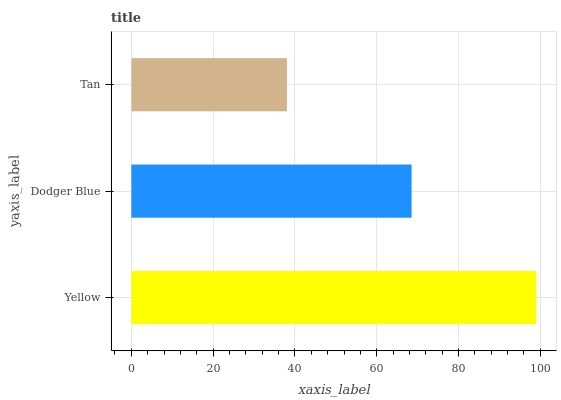Is Tan the minimum?
Answer yes or no. Yes. Is Yellow the maximum?
Answer yes or no. Yes. Is Dodger Blue the minimum?
Answer yes or no. No. Is Dodger Blue the maximum?
Answer yes or no. No. Is Yellow greater than Dodger Blue?
Answer yes or no. Yes. Is Dodger Blue less than Yellow?
Answer yes or no. Yes. Is Dodger Blue greater than Yellow?
Answer yes or no. No. Is Yellow less than Dodger Blue?
Answer yes or no. No. Is Dodger Blue the high median?
Answer yes or no. Yes. Is Dodger Blue the low median?
Answer yes or no. Yes. Is Tan the high median?
Answer yes or no. No. Is Tan the low median?
Answer yes or no. No. 